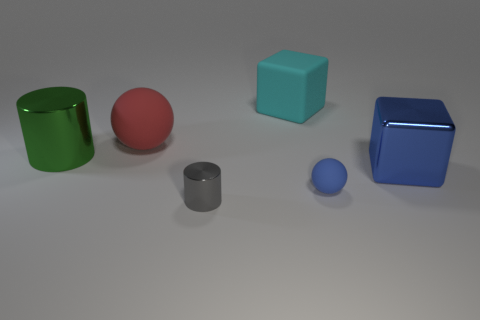Is the number of cylinders that are behind the small gray metal thing greater than the number of large red spheres in front of the big red rubber thing?
Make the answer very short. Yes. What is the shape of the blue thing that is the same size as the green cylinder?
Give a very brief answer. Cube. What number of things are tiny red metal cylinders or large things that are to the right of the red rubber ball?
Offer a terse response. 2. Is the small rubber sphere the same color as the shiny cube?
Make the answer very short. Yes. There is a green cylinder; how many large shiny blocks are on the right side of it?
Your answer should be very brief. 1. The small object that is the same material as the green cylinder is what color?
Make the answer very short. Gray. What number of shiny objects are gray objects or large yellow balls?
Ensure brevity in your answer.  1. Is the material of the big red thing the same as the tiny blue object?
Your answer should be compact. Yes. There is a tiny thing that is left of the blue rubber object; what shape is it?
Make the answer very short. Cylinder. There is a block that is to the right of the large cyan matte cube; is there a shiny object in front of it?
Your answer should be very brief. Yes. 